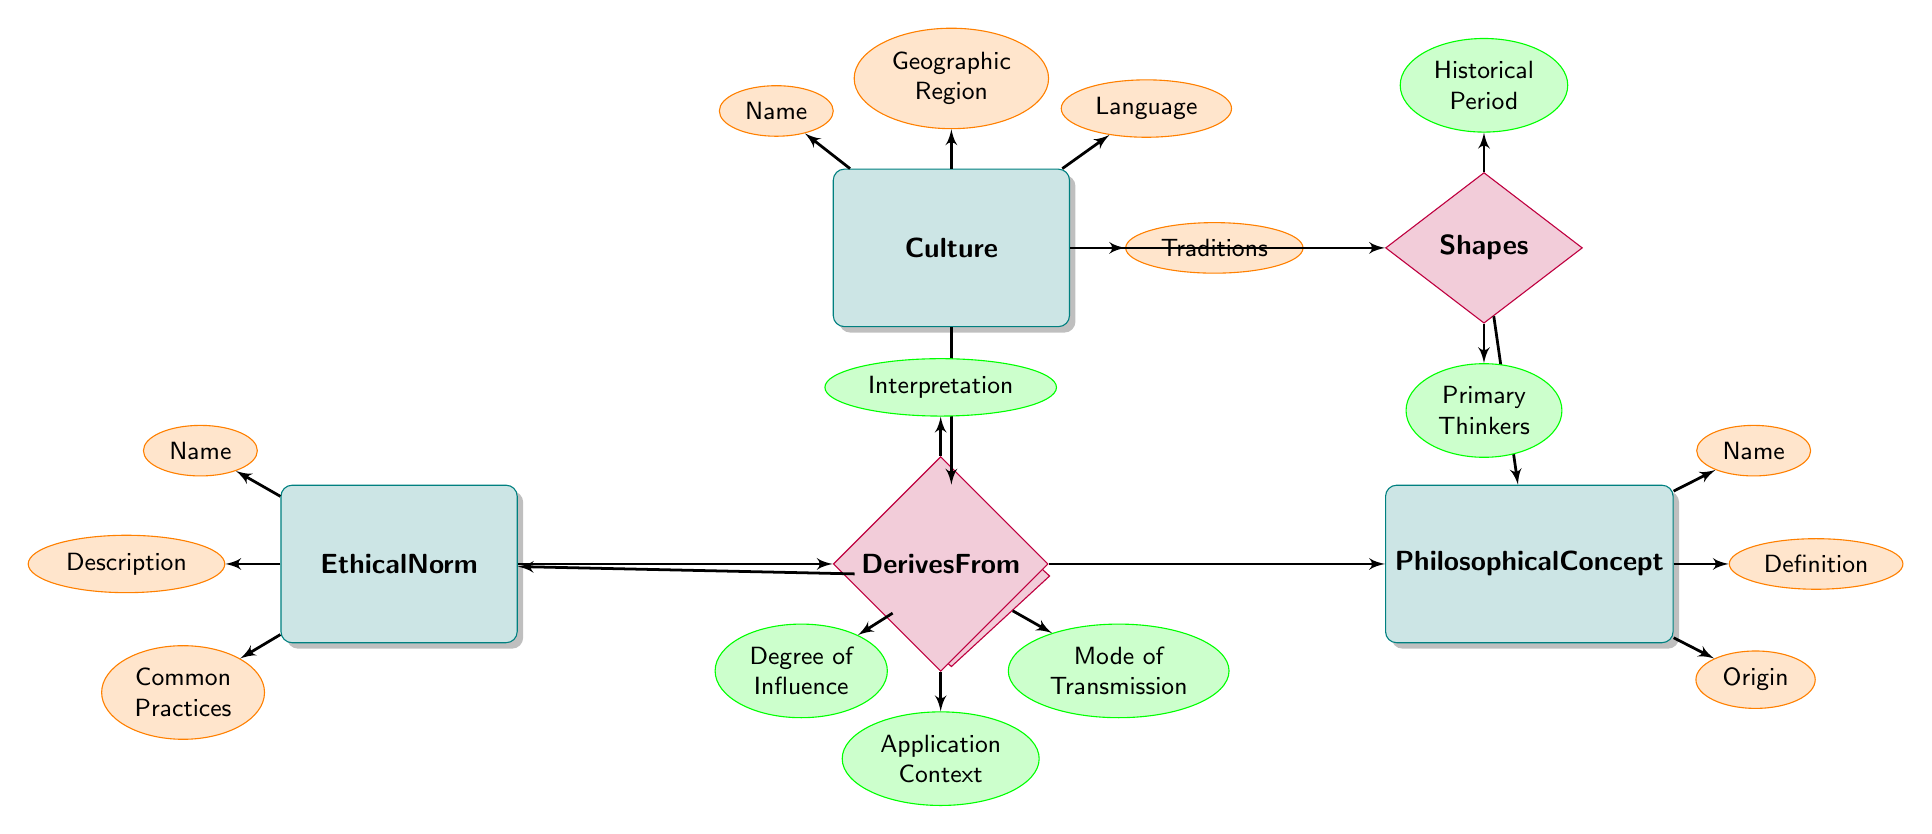What is the primary relationship between Culture and Ethical Norm? The primary relationship between Culture and Ethical Norm is labeled as "Influences". This relationship establishes that Cultural factors play a significant role in shaping Ethical Norms.
Answer: Influences How many attributes does the Ethical Norm entity have? The Ethical Norm entity has three attributes listed: Name, Description, and Common Practices. Counting these yields a total of three attributes.
Answer: 3 What is one attribute of the Philosophical Concept entity? The Philosophical Concept entity has multiple attributes, one of which is "Name". This can be found directly linked to the Philosophical Concept entity in the diagram.
Answer: Name What are the two attributes associated with the relationship "Influences"? The relationship "Influences" is associated with two attributes: Degree of Influence and Mode of Transmission. These attributes are connected directly to the relationship, indicating how the influence is characterized.
Answer: Degree of Influence, Mode of Transmission Which entity derives from the Ethical Norm entity? The relationship labeled "Derives From" indicates that the Philosophical Concept entity derives from the Ethical Norm entity. This means Ethical Norms provide foundational aspects that shape Philosophical Concepts.
Answer: Philosophical Concept What does the relationship "Shapes" connect? The relationship "Shapes" connects Culture and Philosophical Concept entities, indicating that Cultural influences play a role in shaping Philosophical Concepts throughout history.
Answer: Culture and Philosophical Concept What is the mode of transmission dimension in the diagram? The mode of transmission is an attribute related to the "Influences" relationship. It describes how cultural influences are communicated or passed on to shape Ethical Norms.
Answer: Mode of Transmission Name one entity in the diagram. The diagram includes three entities: Culture, Philosophical Concept, and Ethical Norm. Any one of these can serve as an answer to this question.
Answer: Culture 